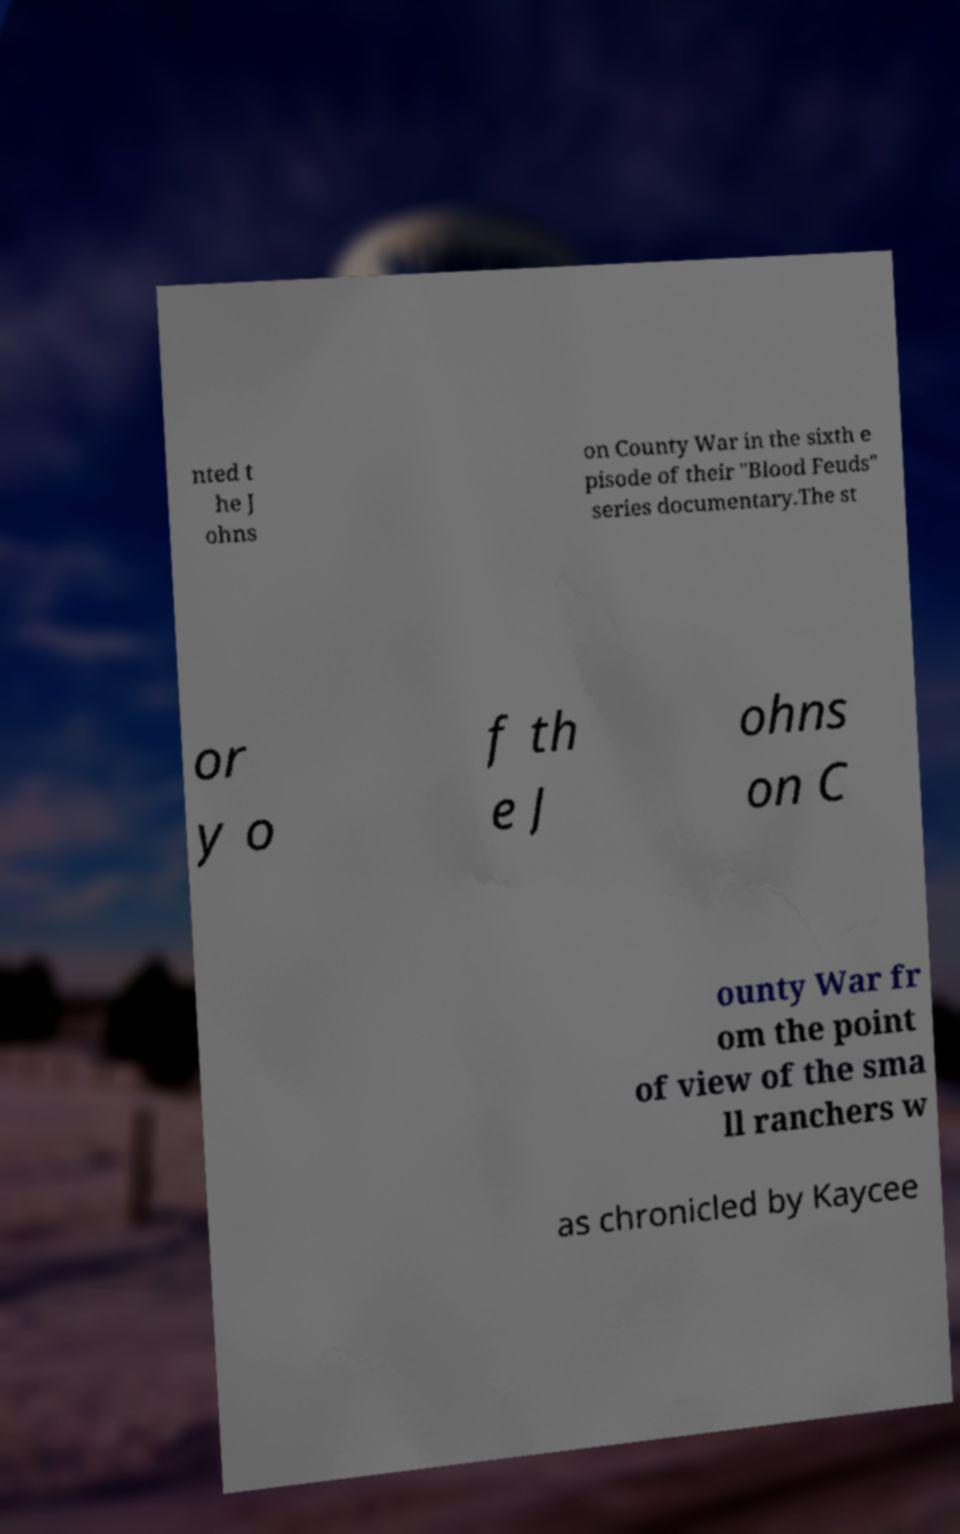Please read and relay the text visible in this image. What does it say? nted t he J ohns on County War in the sixth e pisode of their "Blood Feuds" series documentary.The st or y o f th e J ohns on C ounty War fr om the point of view of the sma ll ranchers w as chronicled by Kaycee 